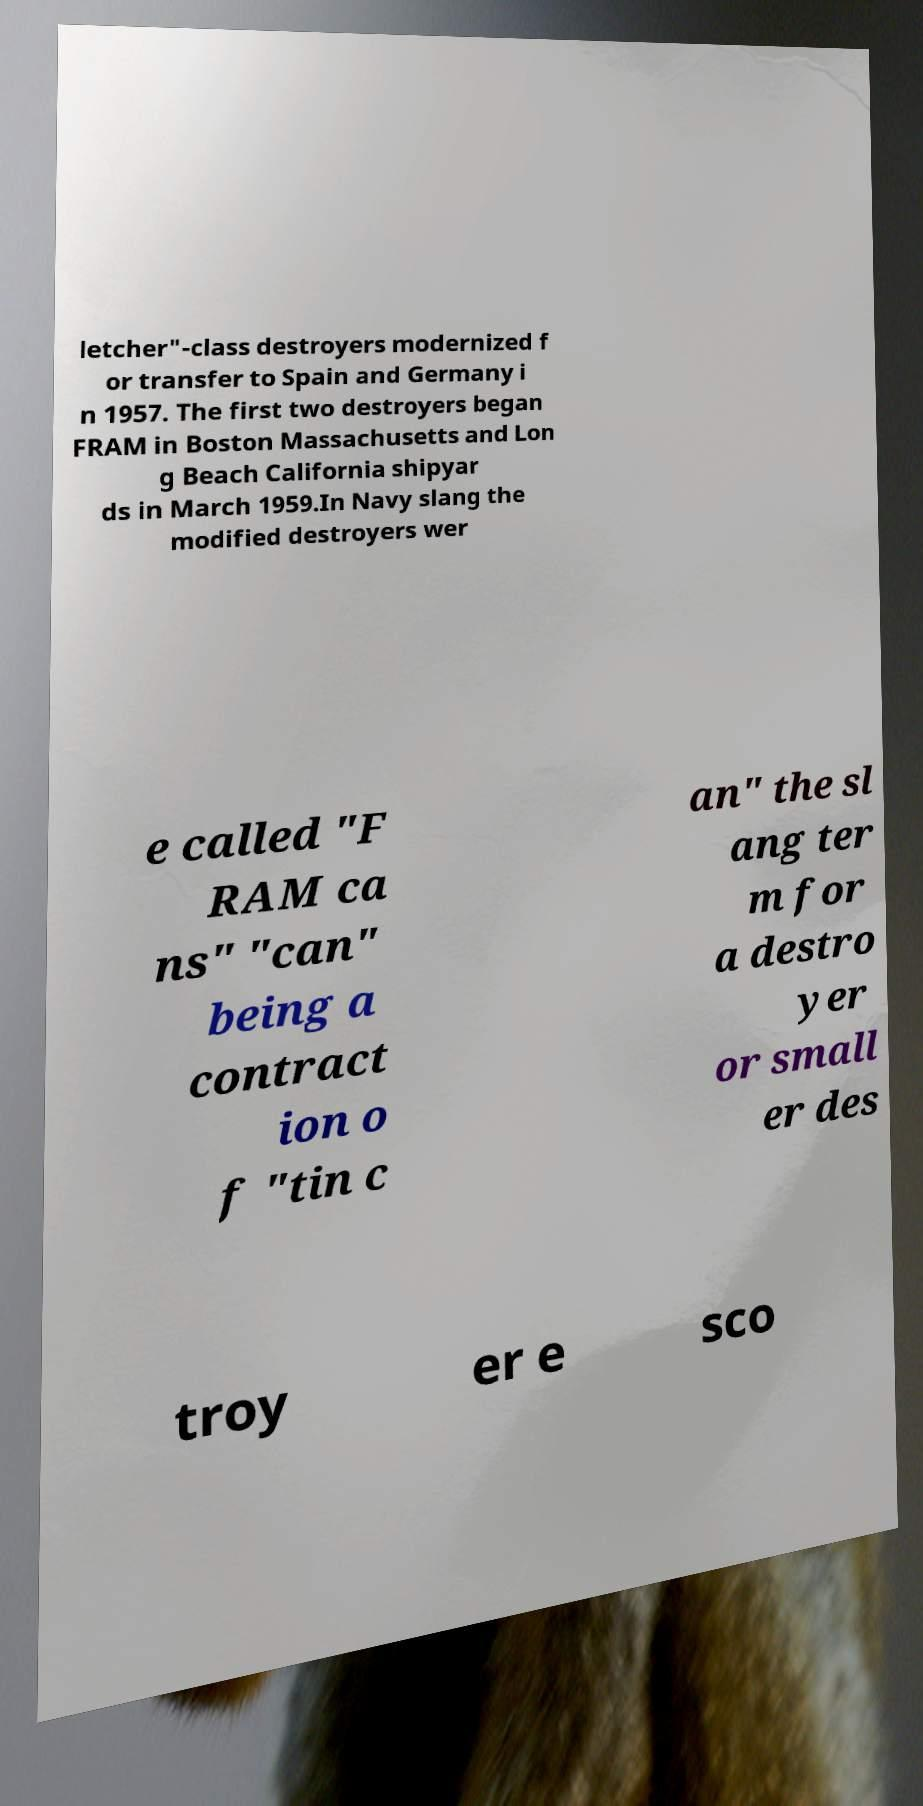Please identify and transcribe the text found in this image. letcher"-class destroyers modernized f or transfer to Spain and Germany i n 1957. The first two destroyers began FRAM in Boston Massachusetts and Lon g Beach California shipyar ds in March 1959.In Navy slang the modified destroyers wer e called "F RAM ca ns" "can" being a contract ion o f "tin c an" the sl ang ter m for a destro yer or small er des troy er e sco 